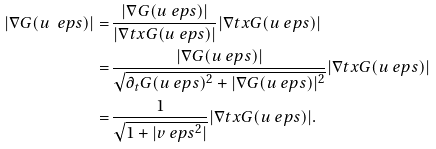Convert formula to latex. <formula><loc_0><loc_0><loc_500><loc_500>| \nabla G ( u _ { \ } e p s ) | = \, & \frac { | \nabla G ( u _ { \ } e p s ) | } { | \nabla t x G ( u _ { \ } e p s ) | } { | \nabla t x G ( u _ { \ } e p s ) | } \\ = \, & \frac { | \nabla G ( u _ { \ } e p s ) | } { \sqrt { \partial _ { t } G ( u _ { \ } e p s ) ^ { 2 } + | \nabla G ( u _ { \ } e p s ) | ^ { 2 } } } { | \nabla t x G ( u _ { \ } e p s ) | } \\ = \, & \frac { 1 } { \sqrt { 1 + | v _ { \ } e p s ^ { 2 } | } } { | \nabla t x G ( u _ { \ } e p s ) | } .</formula> 